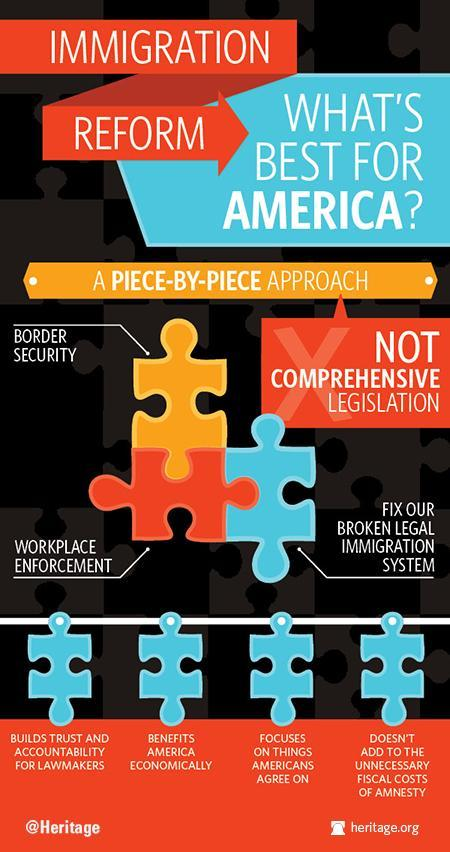What is the colour of piece named border security- yellow, blue or red?
Answer the question with a short phrase. Yellow 